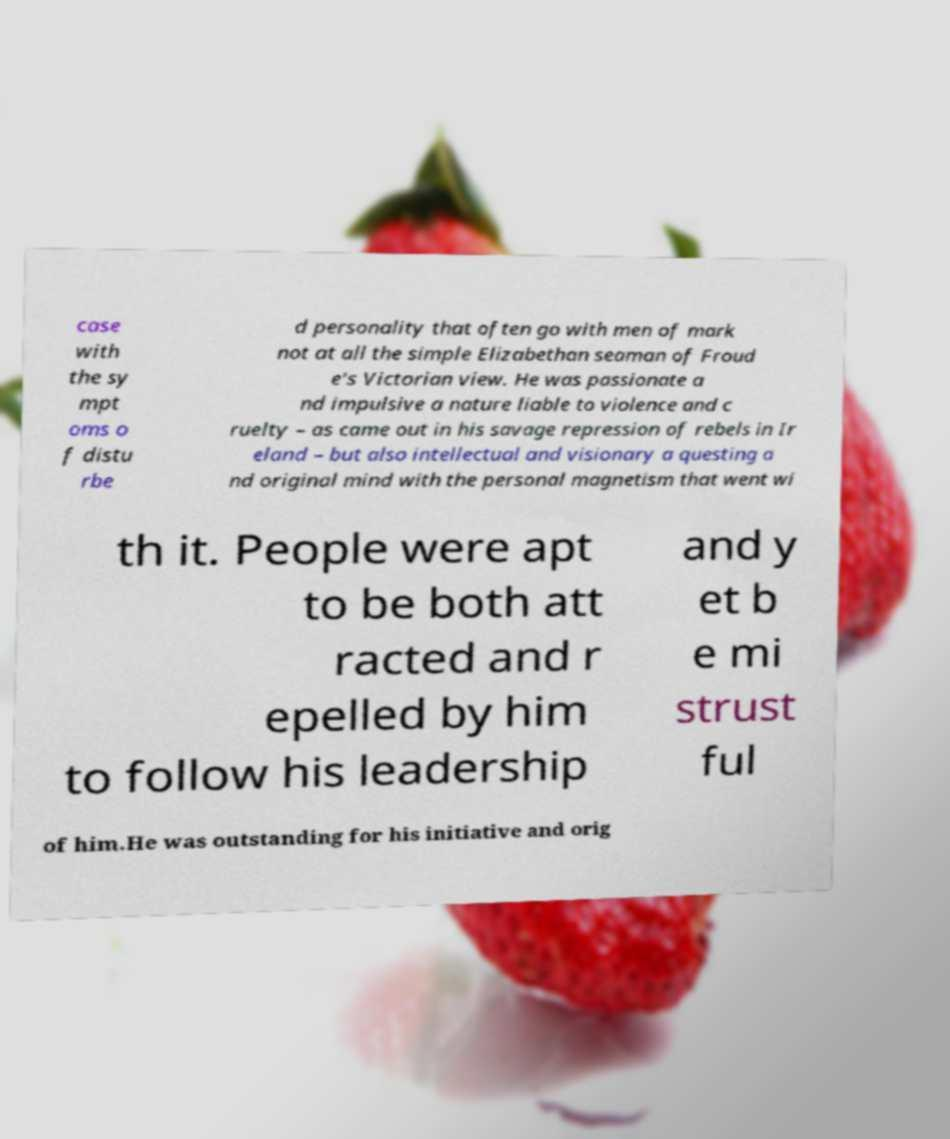Could you extract and type out the text from this image? case with the sy mpt oms o f distu rbe d personality that often go with men of mark not at all the simple Elizabethan seaman of Froud e's Victorian view. He was passionate a nd impulsive a nature liable to violence and c ruelty – as came out in his savage repression of rebels in Ir eland – but also intellectual and visionary a questing a nd original mind with the personal magnetism that went wi th it. People were apt to be both att racted and r epelled by him to follow his leadership and y et b e mi strust ful of him.He was outstanding for his initiative and orig 